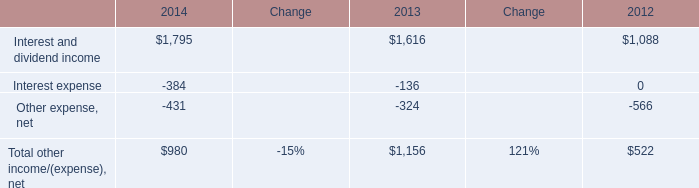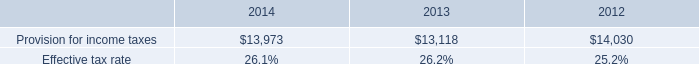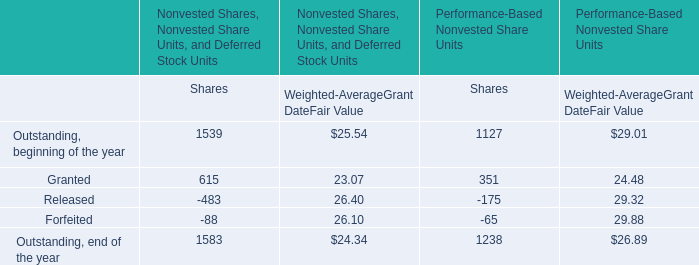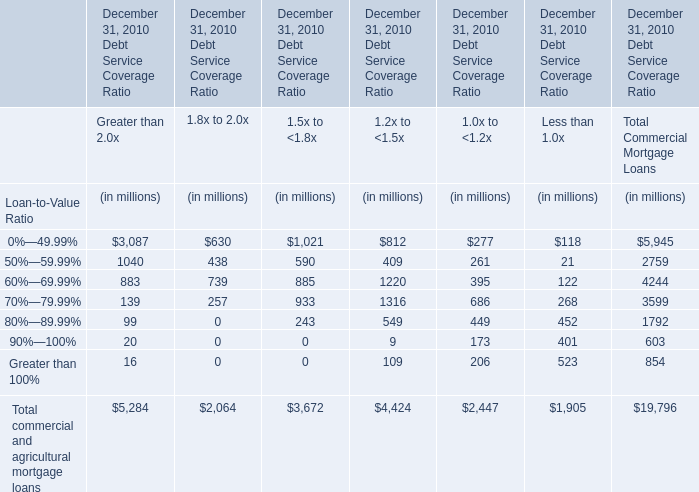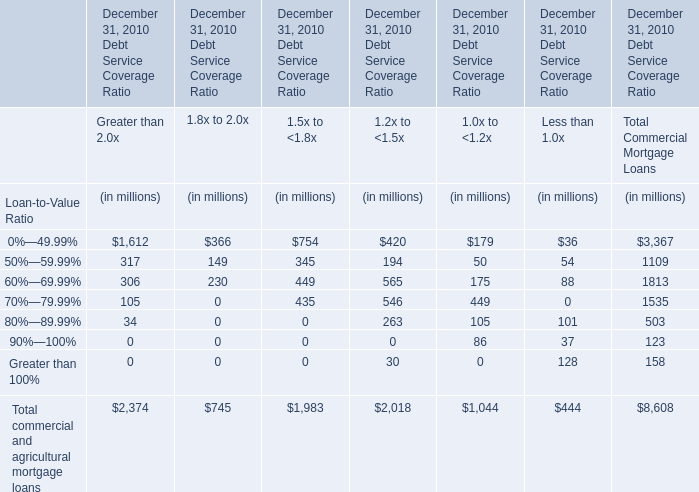What's the sum of all commercial and agricultural mortgage loans for Debt Service Coverage Ratio 1.2x to <1.5x at December 31, 2010 that are positive ? (in million) 
Computations: (((((420 + 194) + 565) + 546) + 263) + 30)
Answer: 2018.0. 